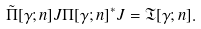<formula> <loc_0><loc_0><loc_500><loc_500>\tilde { \Pi } [ \gamma ; n ] J \Pi [ \gamma ; n ] ^ { * } J = \mathfrak { T } [ \gamma ; n ] .</formula> 